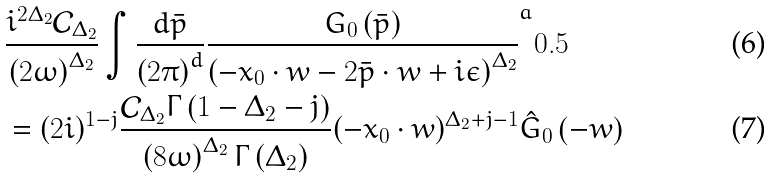<formula> <loc_0><loc_0><loc_500><loc_500>& \frac { i ^ { 2 \Delta _ { 2 } } \mathcal { C } _ { \Delta _ { 2 } } } { \left ( 2 \omega \right ) ^ { \Delta _ { 2 } } } \int \frac { d { \bar { p } } } { \left ( 2 \pi \right ) ^ { d } } \frac { G _ { 0 } \left ( { \bar { p } } \right ) } { \left ( - { x } _ { 0 } \cdot { w } - 2 { \bar { p } } \cdot { w } + i \epsilon \right ) ^ { \Delta _ { 2 } } } ^ { a } { 0 . 5 } \\ & = ( 2 i ) ^ { 1 - j } \frac { \mathcal { C } _ { \Delta _ { 2 } } \Gamma \left ( 1 - \Delta _ { 2 } - j \right ) } { \left ( 8 \omega \right ) ^ { \Delta _ { 2 } } \Gamma \left ( \Delta _ { 2 } \right ) } ( - { x } _ { 0 } \cdot { w } ) ^ { \Delta _ { 2 } + j - 1 } \hat { G } _ { 0 } \left ( - { w } \right )</formula> 